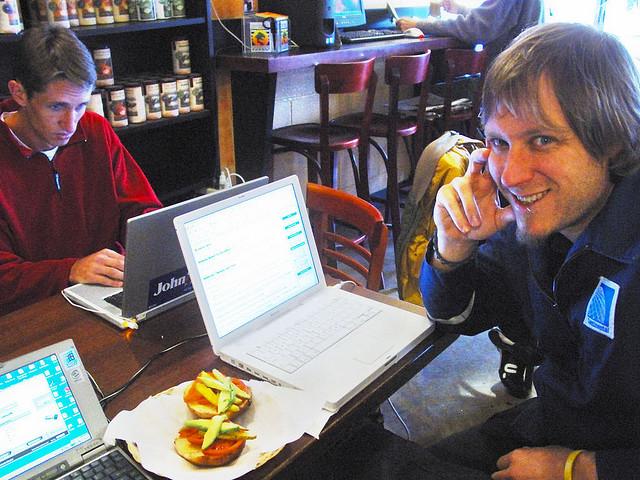How many computers are in this picture?
Concise answer only. 4. How many eyebrows does the man have?
Be succinct. 2. What type of computers are in the picture?
Keep it brief. Laptops. 